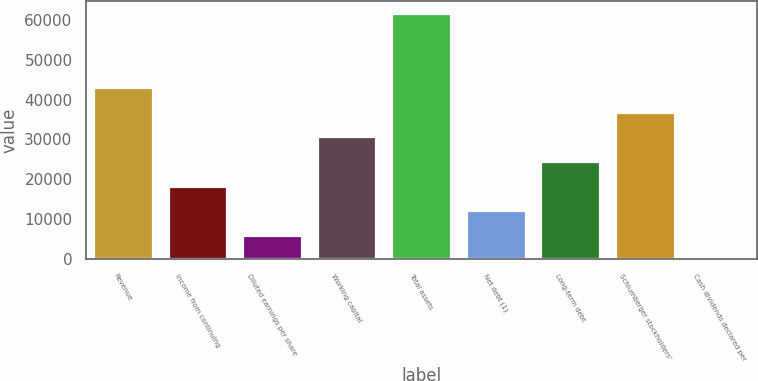<chart> <loc_0><loc_0><loc_500><loc_500><bar_chart><fcel>Revenue<fcel>Income from continuing<fcel>Diluted earnings per share<fcel>Working capital<fcel>Total assets<fcel>Net debt (1)<fcel>Long-term debt<fcel>Schlumberger stockholders'<fcel>Cash dividends declared per<nl><fcel>43083.2<fcel>18464.9<fcel>6155.69<fcel>30774<fcel>61547<fcel>12310.3<fcel>24619.5<fcel>36928.6<fcel>1.1<nl></chart> 